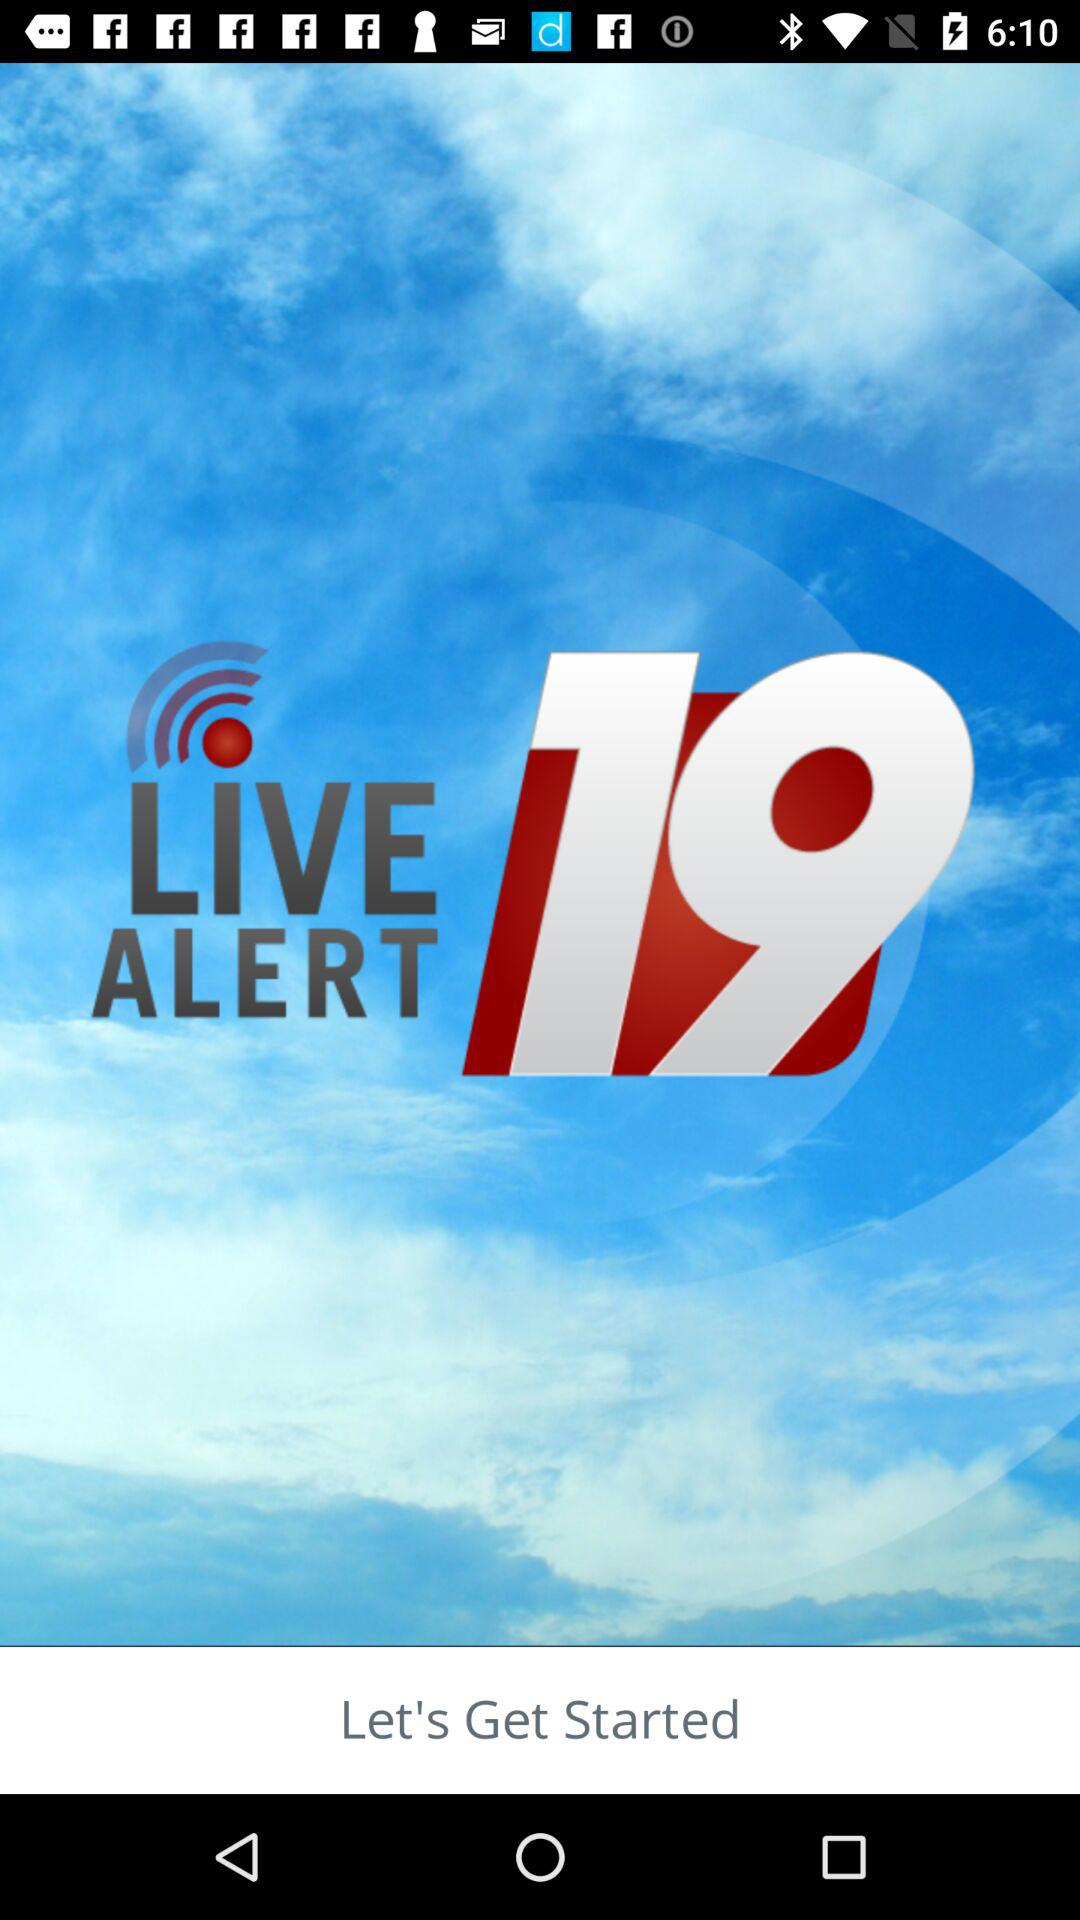What is the name of the application? The name of the application is "LIVE ALERT 19". 